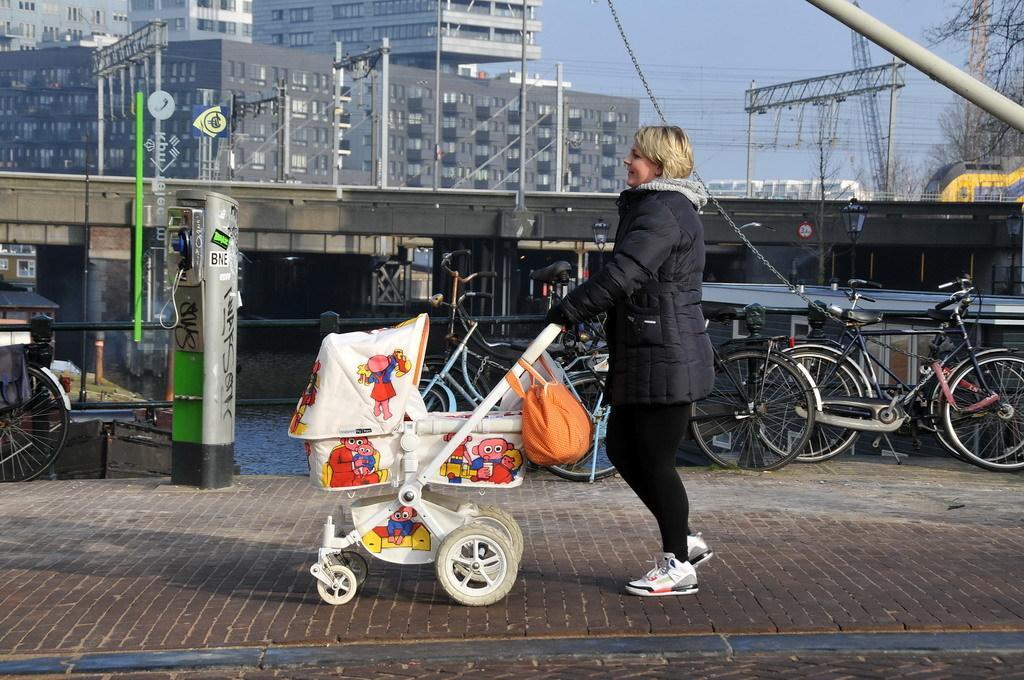Describe this image in one or two sentences. Here in this picture we can see a woman wearing a black colored jacket on her walking on the ground over there and we can see she is pushing the baby stroller, which is present in front of her over there and we can also see a hand bag on the stroller over there and beside her we can see number of bicycles present and on the left side we can see a telephone present and we can also see a bridge over there and we can see a train running over there and in the far we can see buildings present and we can also see electric poles, crane and trees also present over there. 